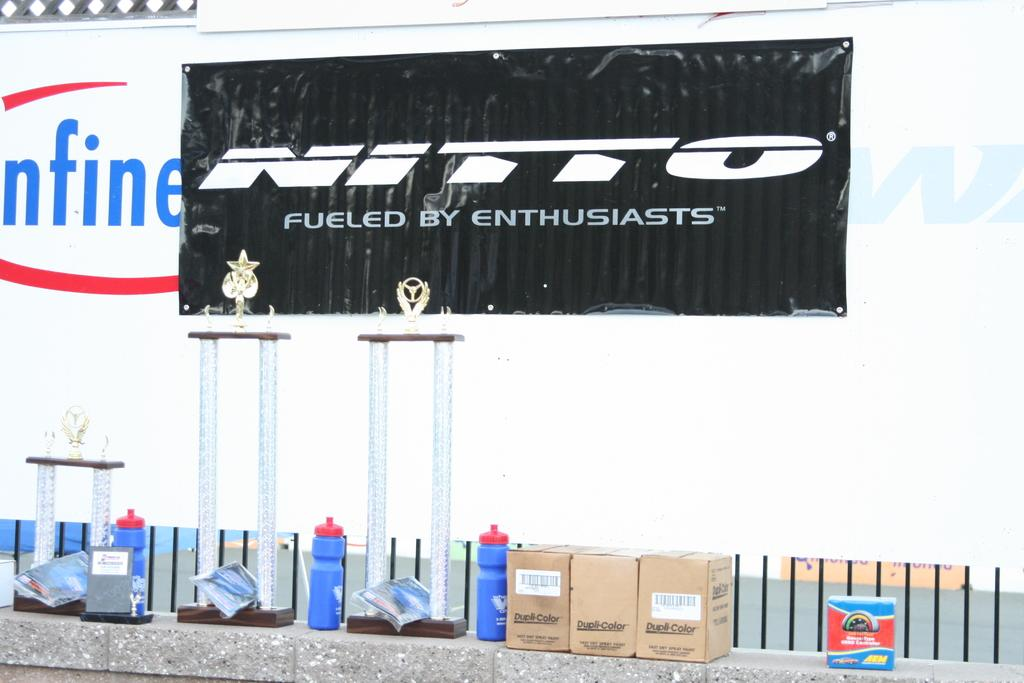<image>
Present a compact description of the photo's key features. A black sign is advertising NITTO, fueled by enthusiasts. 